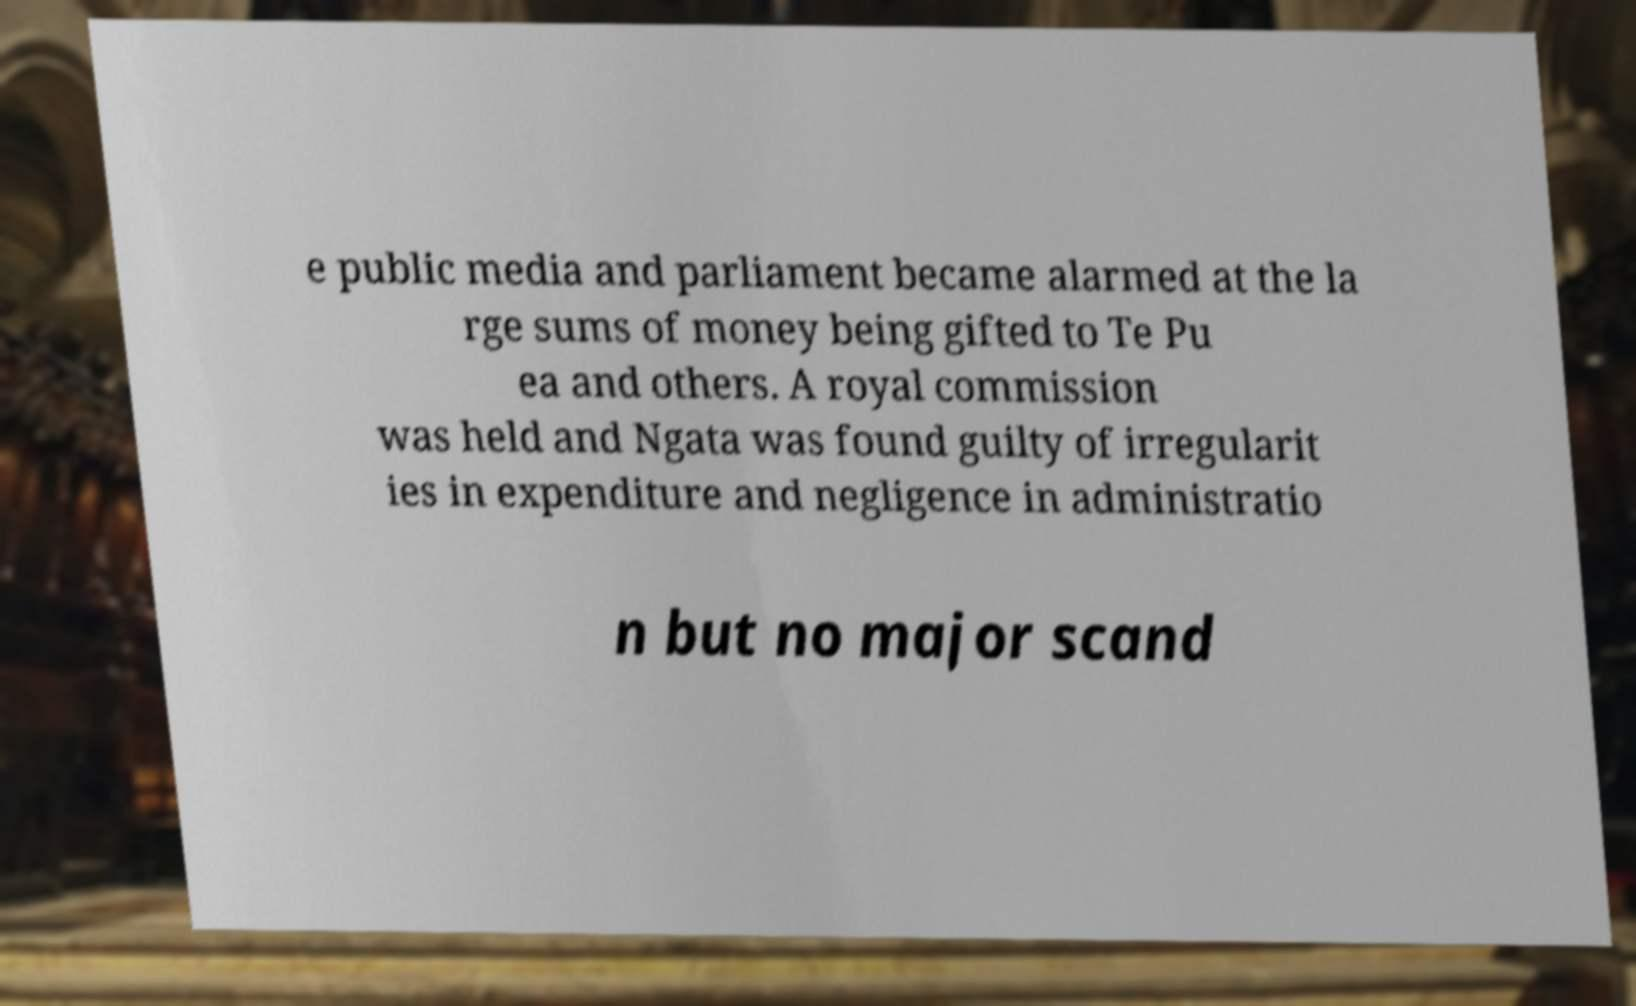For documentation purposes, I need the text within this image transcribed. Could you provide that? e public media and parliament became alarmed at the la rge sums of money being gifted to Te Pu ea and others. A royal commission was held and Ngata was found guilty of irregularit ies in expenditure and negligence in administratio n but no major scand 